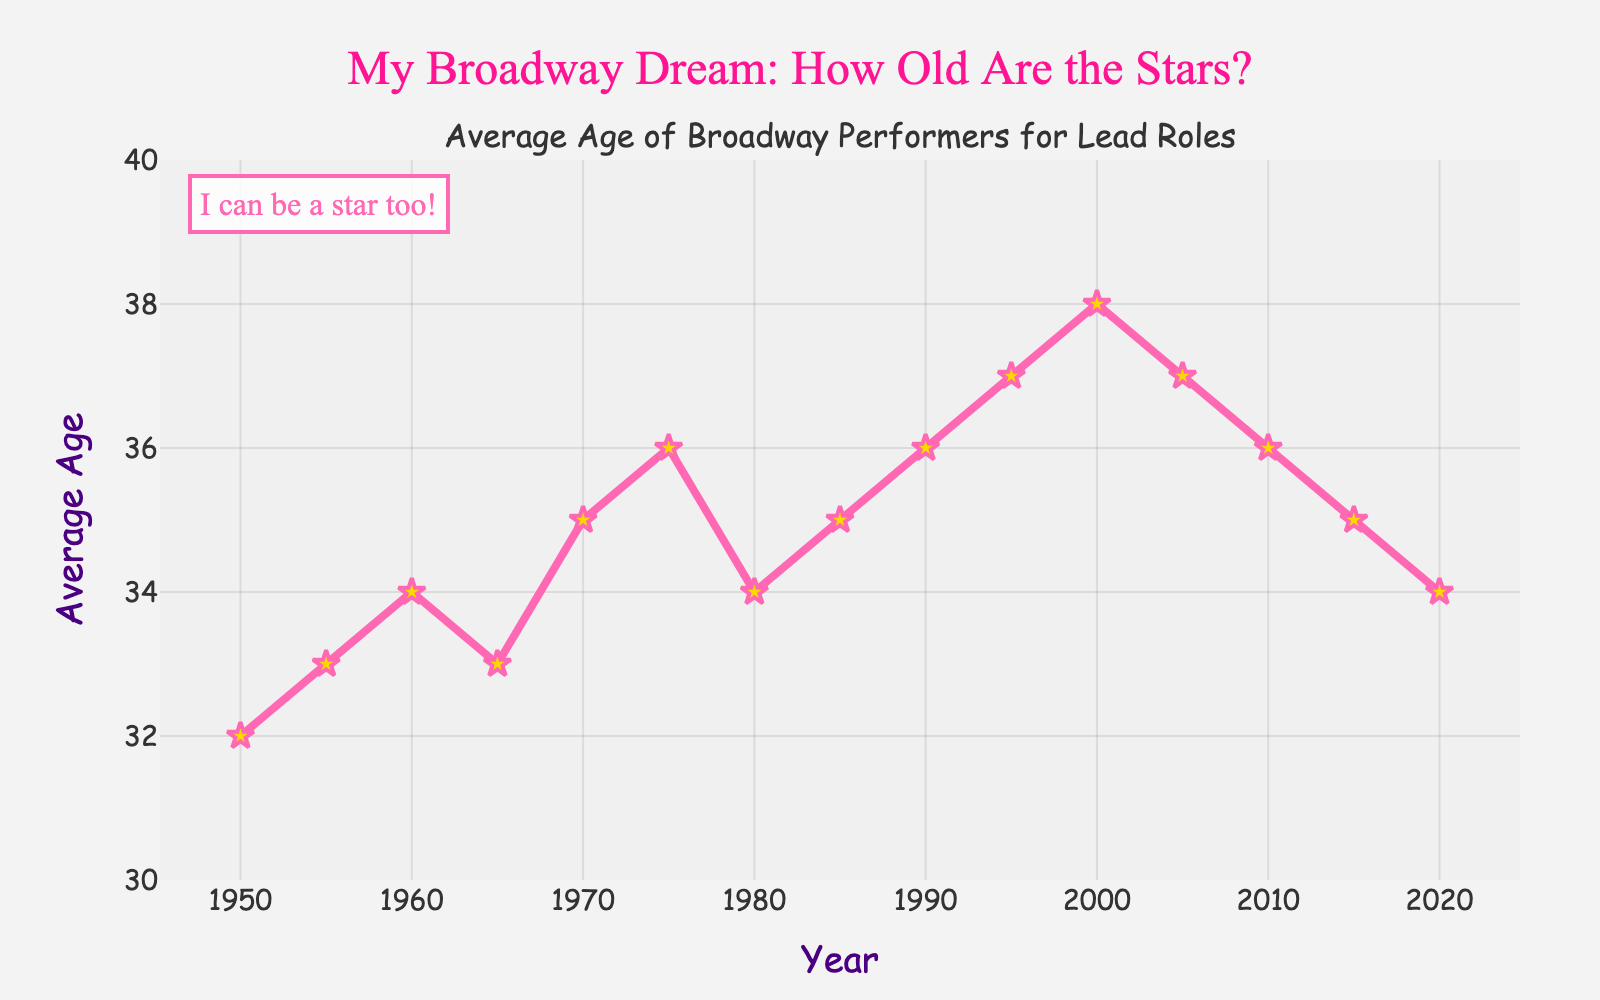What's the highest average age depicted on the chart? The highest point on the y-axis occurs at 38 in the year 2000.
Answer: 38 What's the lowest average age depicted on the chart? The lowest point on the y-axis occurs at 32 in the year 1950.
Answer: 32 How does the average age in 1980 compare to that in 1990? The average age in 1980 is 34, while in 1990 it is 36. 36 is greater than 34 by 2 years.
Answer: The average age in 1990 is 2 years higher than in 1980 What is the trend in average age from 2000 to 2015? From 2000, the average age decreases from 38 to 36 in 2010, and then further to 35 in 2015. The trend is generally downward.
Answer: The trend is decreasing Based on the chart, what was the average age in the mid-1970s? Checking the year 1975 on the x-axis, the average age data point on the y-axis is 36.
Answer: 36 Is there a noticeable trend in the average age from 1950 to 2000? From 1950 (32) to 2000 (38), the average age generally increases with some slight fluctuations.
Answer: The trend is generally increasing What is the range of the average ages depicted in the plot? The range is calculated by subtracting the lowest average age (32) from the highest (38). 38 - 32 = 6.
Answer: 6 How did the average age change between 1950 and 1965? In 1950, the average age is 32, and in 1965, it is 33. The average age increased by 1 year.
Answer: Increased by 1 year In which years did the average age remain constant according to the chart? The average age was 35 in both 1985 and 1970, and 37 in both 1995 and 2005. These were the years where it did not change.
Answer: 1985, 1970, 1995, 2005 exclamations delta increase 